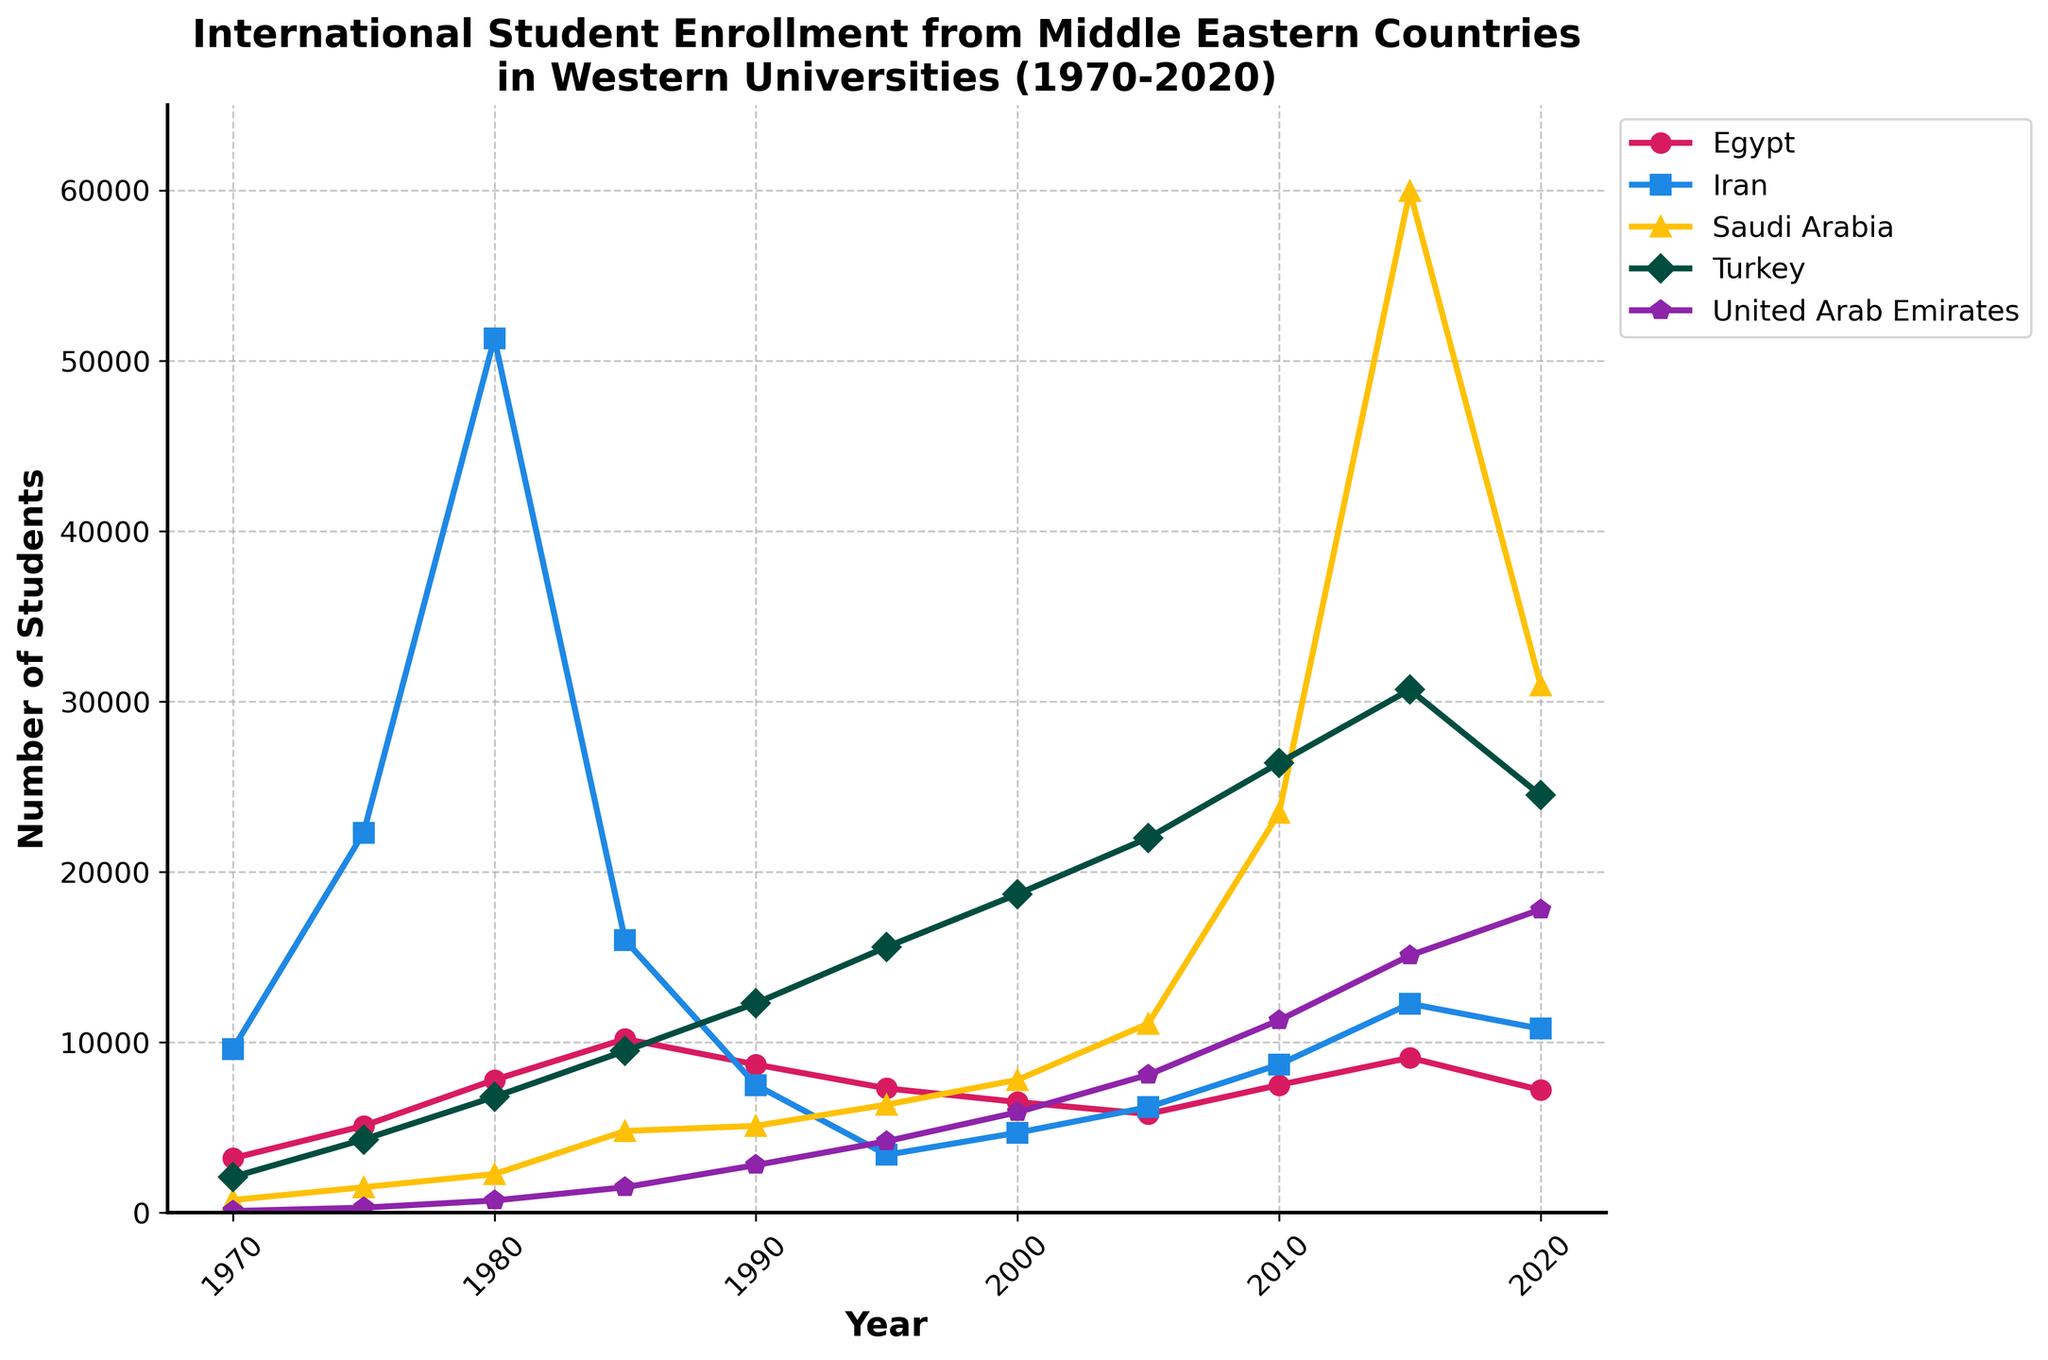Which country had the highest number of international students enrolled in 1980? Look at the data points for each country in 1980. Iran has the highest value at 51,310 students.
Answer: Iran Which year saw the highest enrollment of Saudi Arabian students? Observe the data line for Saudi Arabia and find the highest peak. The highest enrollment for Saudi Arabia is in 2015, with 59,945 students.
Answer: 2015 Between which consecutive years did Turkey see the largest increase in student enrollment? Compare the differences in data points year-to-year for Turkey. The largest increase occurred between 1970 (2100) and 1975 (4300), which is an increase of 2200 students.
Answer: 1970 to 1975 How does the trend of UAE students' enrollment between 2010 and 2020 compare to that of Egyptian students? Examine the data lines for UAE and Egypt between 2010 and 2020. UAE shows an increasing trend (11300 to 17800), whereas Egypt shows a decreasing trend (7500 to 7200).
Answer: UAE's enrollment increased while Egypt's decreased What is the average student enrollment for Iran in the years provided? Add up all the enrollment numbers for Iran and divide by the number of data points (10 years): (9600 + 22300 + 51310 + 16000 + 7500 + 3400 + 4700 + 6200 + 8700 + 12270) / 10 = 142398 / 10 = 14239.8
Answer: 14239.8 Which country had a sharp decline in student enrollment between 1980 and 1985? Examine the slopes between 1980 and 1985 for all countries. Iran had a sharp decline from 51,310 to 16,000 students.
Answer: Iran How did the enrollment numbers for UAE change from 1995 to 2000? Look at the data points for UAE: from 1995 (4200) to 2000 (5900), the number increased by 1700 students.
Answer: Increased by 1700 